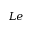<formula> <loc_0><loc_0><loc_500><loc_500>L e</formula> 